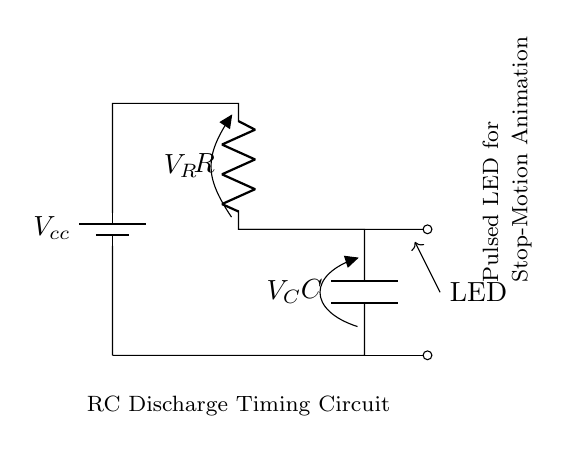What is the component connected to the battery? The component connected to the battery is a resistor, as shown in the circuit diagram where the positive terminal of the battery connects to it.
Answer: Resistor What type of circuit is this? This is an RC discharge timing circuit, which consists of a resistor and capacitor connected to achieve a specific timing function.
Answer: RC discharge timing What is the value of the voltage across the capacitor? The voltage across the capacitor is represented as V_C in the circuit diagram, indicating it can vary during discharge but is initially charged to the battery voltage.
Answer: V_C What happens to the LED when the capacitor discharges? When the capacitor discharges, it provides current through the LED, causing it to light up for a short period dependent on the RC timing.
Answer: Lights up How does increasing the capacitance affect the discharge time? Increasing the capacitance will lengthen the discharge time, as it takes more time for a larger capacitor to discharge its stored energy through the resistor.
Answer: Lengthens What is the relationship between resistor value and the LED pulsing frequency? The resistor value directly affects the time constant (τ = R*C), which in turn regulates the LED pulsing frequency; higher resistance results in lower frequency.
Answer: Inversely related 